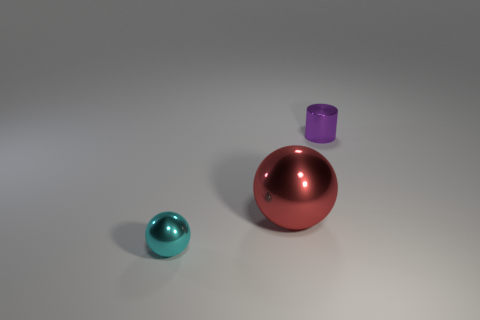Add 1 spheres. How many objects exist? 4 Subtract all cyan balls. How many balls are left? 1 Subtract all spheres. How many objects are left? 1 Subtract all cyan cylinders. Subtract all cyan cubes. How many cylinders are left? 1 Subtract all purple cylinders. How many yellow spheres are left? 0 Subtract all purple metal cylinders. Subtract all purple cylinders. How many objects are left? 1 Add 3 tiny purple shiny cylinders. How many tiny purple shiny cylinders are left? 4 Add 3 purple rubber cylinders. How many purple rubber cylinders exist? 3 Subtract 1 purple cylinders. How many objects are left? 2 